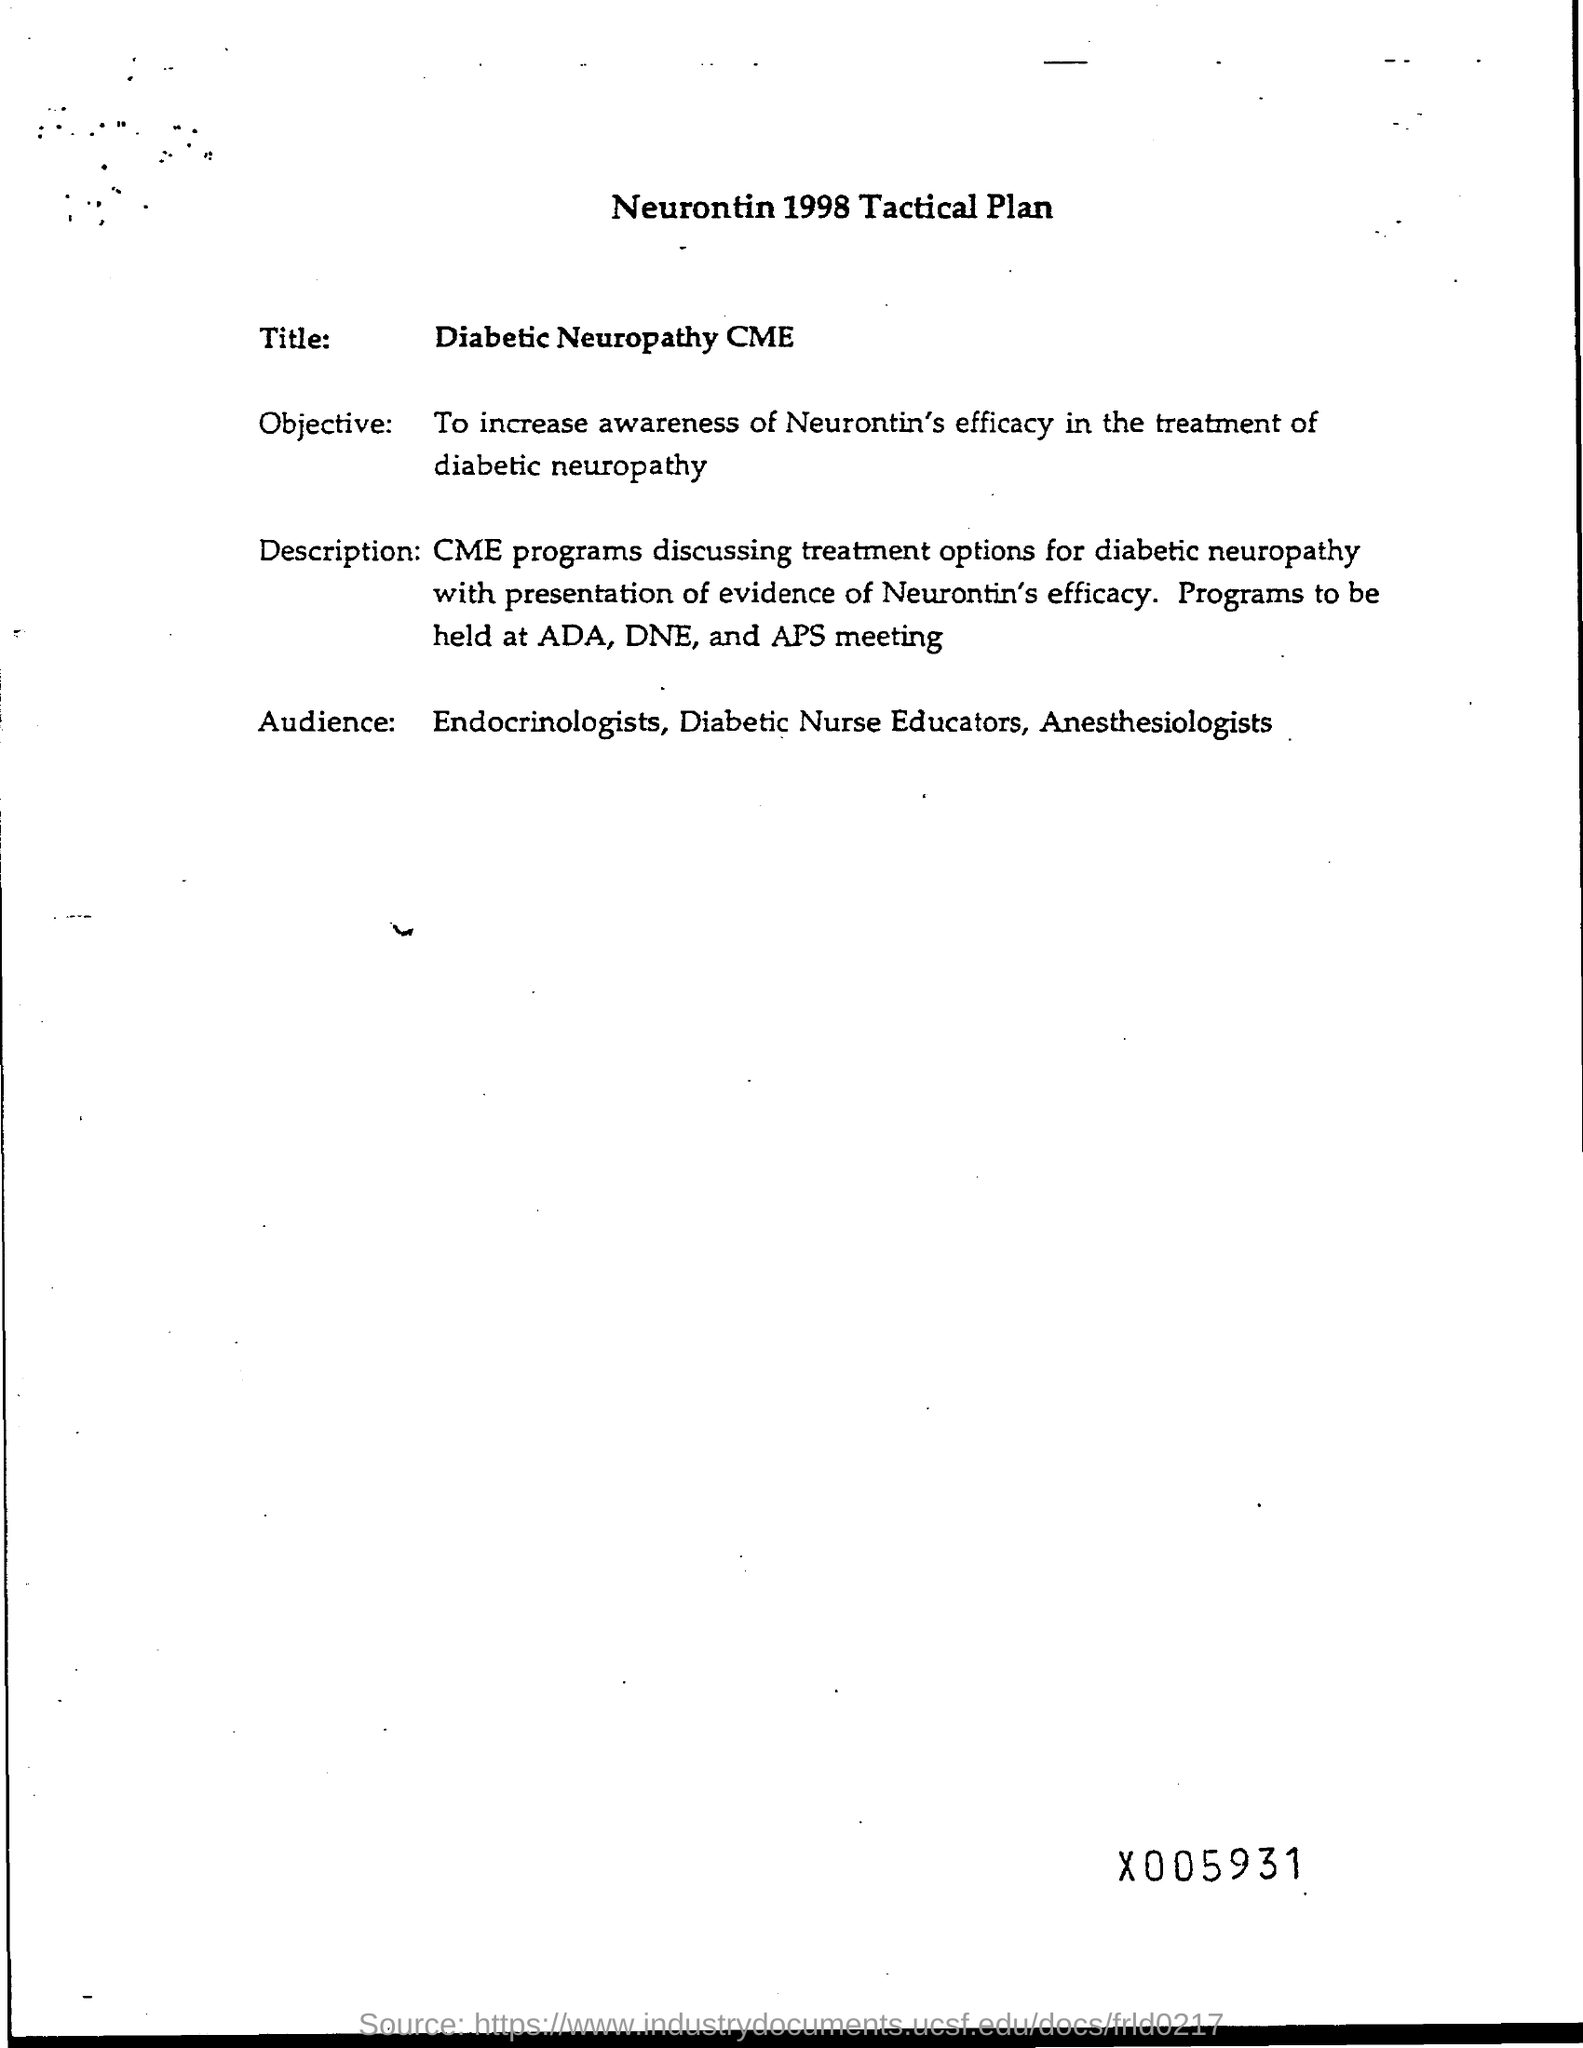Outline some significant characteristics in this image. Where will the programs be held? They will be held at ADA, DNE, and APS. The objective is to raise awareness of the effectiveness of Neurontin in treating diabetic neuropathy. The intended audience for this continuing medical education activity includes endocrinologists, diabetic nurse educators, and anesthesiologists. 